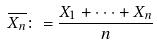<formula> <loc_0><loc_0><loc_500><loc_500>\overline { X _ { n } } \colon = \frac { X _ { 1 } + \cdot \cdot \cdot + X _ { n } } { n }</formula> 